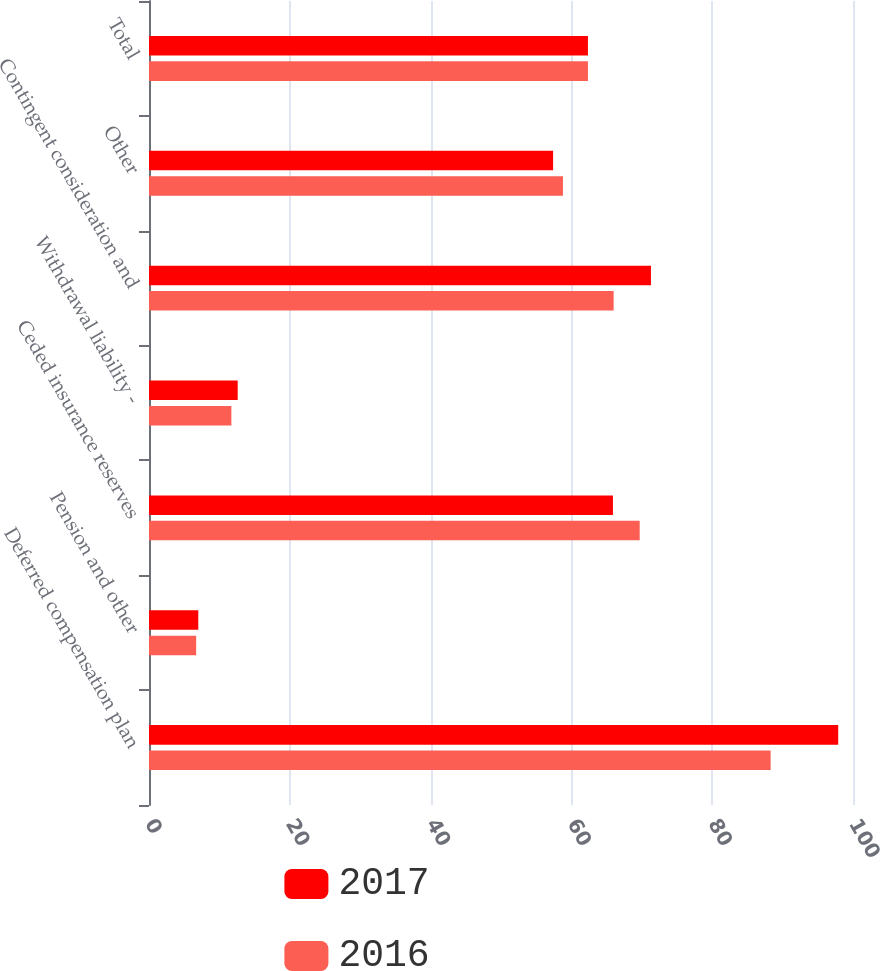<chart> <loc_0><loc_0><loc_500><loc_500><stacked_bar_chart><ecel><fcel>Deferred compensation plan<fcel>Pension and other<fcel>Ceded insurance reserves<fcel>Withdrawal liability -<fcel>Contingent consideration and<fcel>Other<fcel>Total<nl><fcel>2017<fcel>97.9<fcel>7<fcel>65.9<fcel>12.6<fcel>71.3<fcel>57.4<fcel>62.35<nl><fcel>2016<fcel>88.3<fcel>6.7<fcel>69.7<fcel>11.7<fcel>66<fcel>58.8<fcel>62.35<nl></chart> 